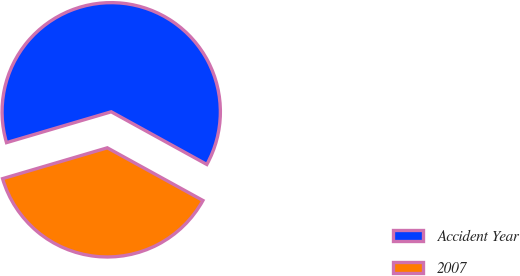<chart> <loc_0><loc_0><loc_500><loc_500><pie_chart><fcel>Accident Year<fcel>2007<nl><fcel>62.57%<fcel>37.43%<nl></chart> 